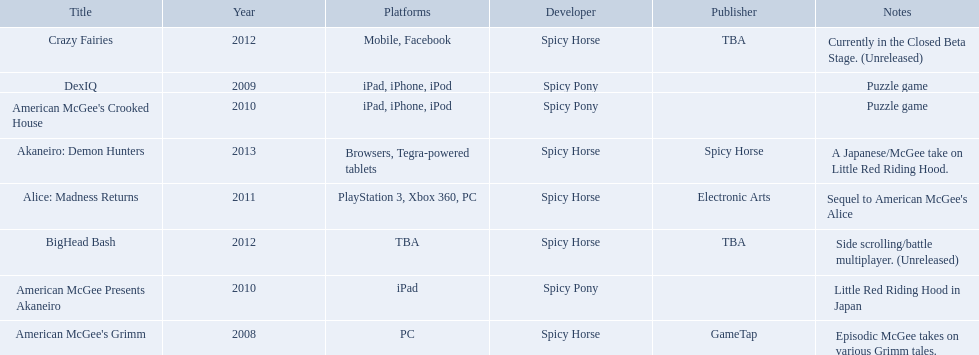Which spicy horse titles are shown? American McGee's Grimm, DexIQ, American McGee Presents Akaneiro, American McGee's Crooked House, Alice: Madness Returns, BigHead Bash, Crazy Fairies, Akaneiro: Demon Hunters. Of those, which are for the ipad? DexIQ, American McGee Presents Akaneiro, American McGee's Crooked House. Which of those are not for the iphone or ipod? American McGee Presents Akaneiro. 